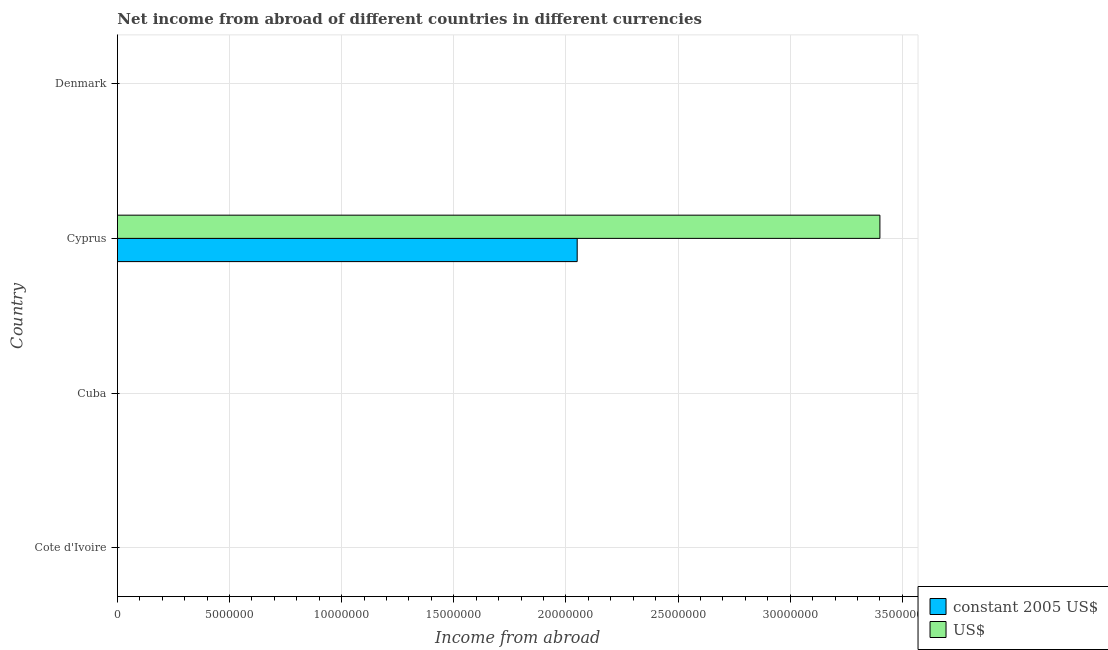How many different coloured bars are there?
Give a very brief answer. 2. Are the number of bars on each tick of the Y-axis equal?
Give a very brief answer. No. How many bars are there on the 1st tick from the top?
Keep it short and to the point. 0. How many bars are there on the 4th tick from the bottom?
Ensure brevity in your answer.  0. What is the label of the 4th group of bars from the top?
Give a very brief answer. Cote d'Ivoire. What is the income from abroad in us$ in Denmark?
Your answer should be compact. 0. Across all countries, what is the maximum income from abroad in us$?
Ensure brevity in your answer.  3.40e+07. Across all countries, what is the minimum income from abroad in constant 2005 us$?
Keep it short and to the point. 0. In which country was the income from abroad in constant 2005 us$ maximum?
Your answer should be very brief. Cyprus. What is the total income from abroad in constant 2005 us$ in the graph?
Your answer should be very brief. 2.05e+07. What is the difference between the income from abroad in constant 2005 us$ in Cote d'Ivoire and the income from abroad in us$ in Cyprus?
Provide a succinct answer. -3.40e+07. What is the average income from abroad in us$ per country?
Make the answer very short. 8.50e+06. What is the difference between the income from abroad in constant 2005 us$ and income from abroad in us$ in Cyprus?
Offer a terse response. -1.35e+07. In how many countries, is the income from abroad in constant 2005 us$ greater than 13000000 units?
Your answer should be very brief. 1. What is the difference between the highest and the lowest income from abroad in constant 2005 us$?
Ensure brevity in your answer.  2.05e+07. Where does the legend appear in the graph?
Give a very brief answer. Bottom right. What is the title of the graph?
Your response must be concise. Net income from abroad of different countries in different currencies. Does "By country of asylum" appear as one of the legend labels in the graph?
Ensure brevity in your answer.  No. What is the label or title of the X-axis?
Give a very brief answer. Income from abroad. What is the Income from abroad in constant 2005 US$ in Cote d'Ivoire?
Provide a succinct answer. 0. What is the Income from abroad in US$ in Cote d'Ivoire?
Your answer should be compact. 0. What is the Income from abroad in US$ in Cuba?
Your answer should be very brief. 0. What is the Income from abroad in constant 2005 US$ in Cyprus?
Offer a terse response. 2.05e+07. What is the Income from abroad in US$ in Cyprus?
Your answer should be compact. 3.40e+07. Across all countries, what is the maximum Income from abroad in constant 2005 US$?
Provide a succinct answer. 2.05e+07. Across all countries, what is the maximum Income from abroad in US$?
Your answer should be compact. 3.40e+07. Across all countries, what is the minimum Income from abroad of constant 2005 US$?
Provide a short and direct response. 0. What is the total Income from abroad of constant 2005 US$ in the graph?
Offer a terse response. 2.05e+07. What is the total Income from abroad in US$ in the graph?
Provide a succinct answer. 3.40e+07. What is the average Income from abroad of constant 2005 US$ per country?
Ensure brevity in your answer.  5.13e+06. What is the average Income from abroad of US$ per country?
Provide a succinct answer. 8.50e+06. What is the difference between the Income from abroad of constant 2005 US$ and Income from abroad of US$ in Cyprus?
Offer a very short reply. -1.35e+07. What is the difference between the highest and the lowest Income from abroad in constant 2005 US$?
Offer a very short reply. 2.05e+07. What is the difference between the highest and the lowest Income from abroad of US$?
Make the answer very short. 3.40e+07. 